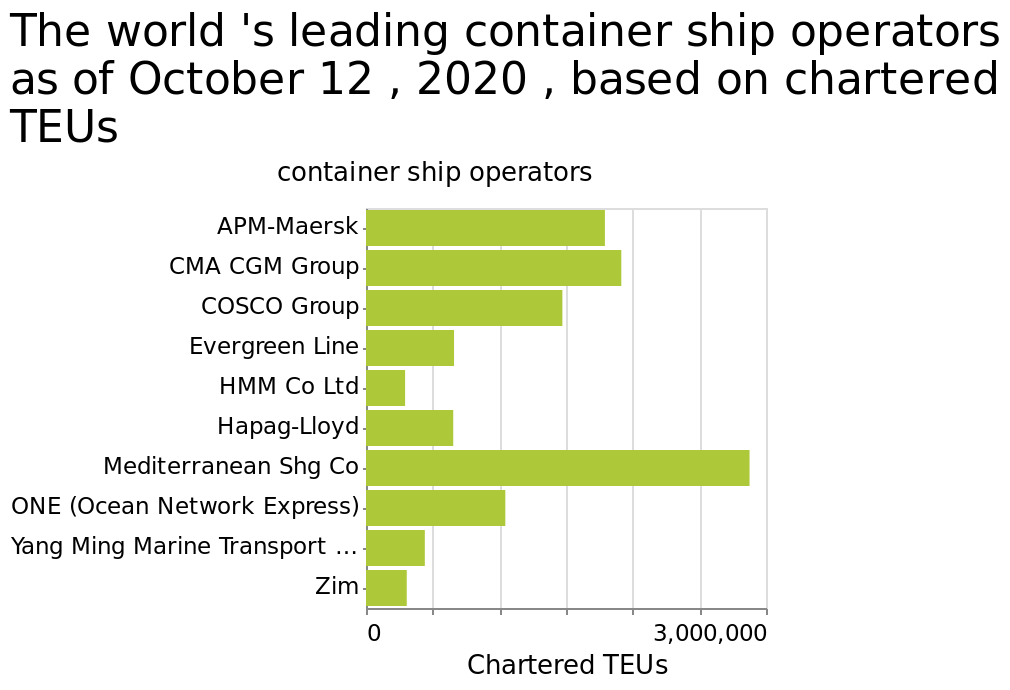<image>
What is the date of the data represented in the bar graph?  The date of the data represented in the bar graph is October 12, 2020. What is the range of the x-axis values on the bar graph?  The x-axis values on the bar graph range from a minimum of 0 to a maximum of 3,000,000 Chartered TEUs. Which measurement is represented on the x-axis of the bar graph?  The x-axis of the bar graph represents the Chartered TEUs (Twenty-foot Equivalent Units). 